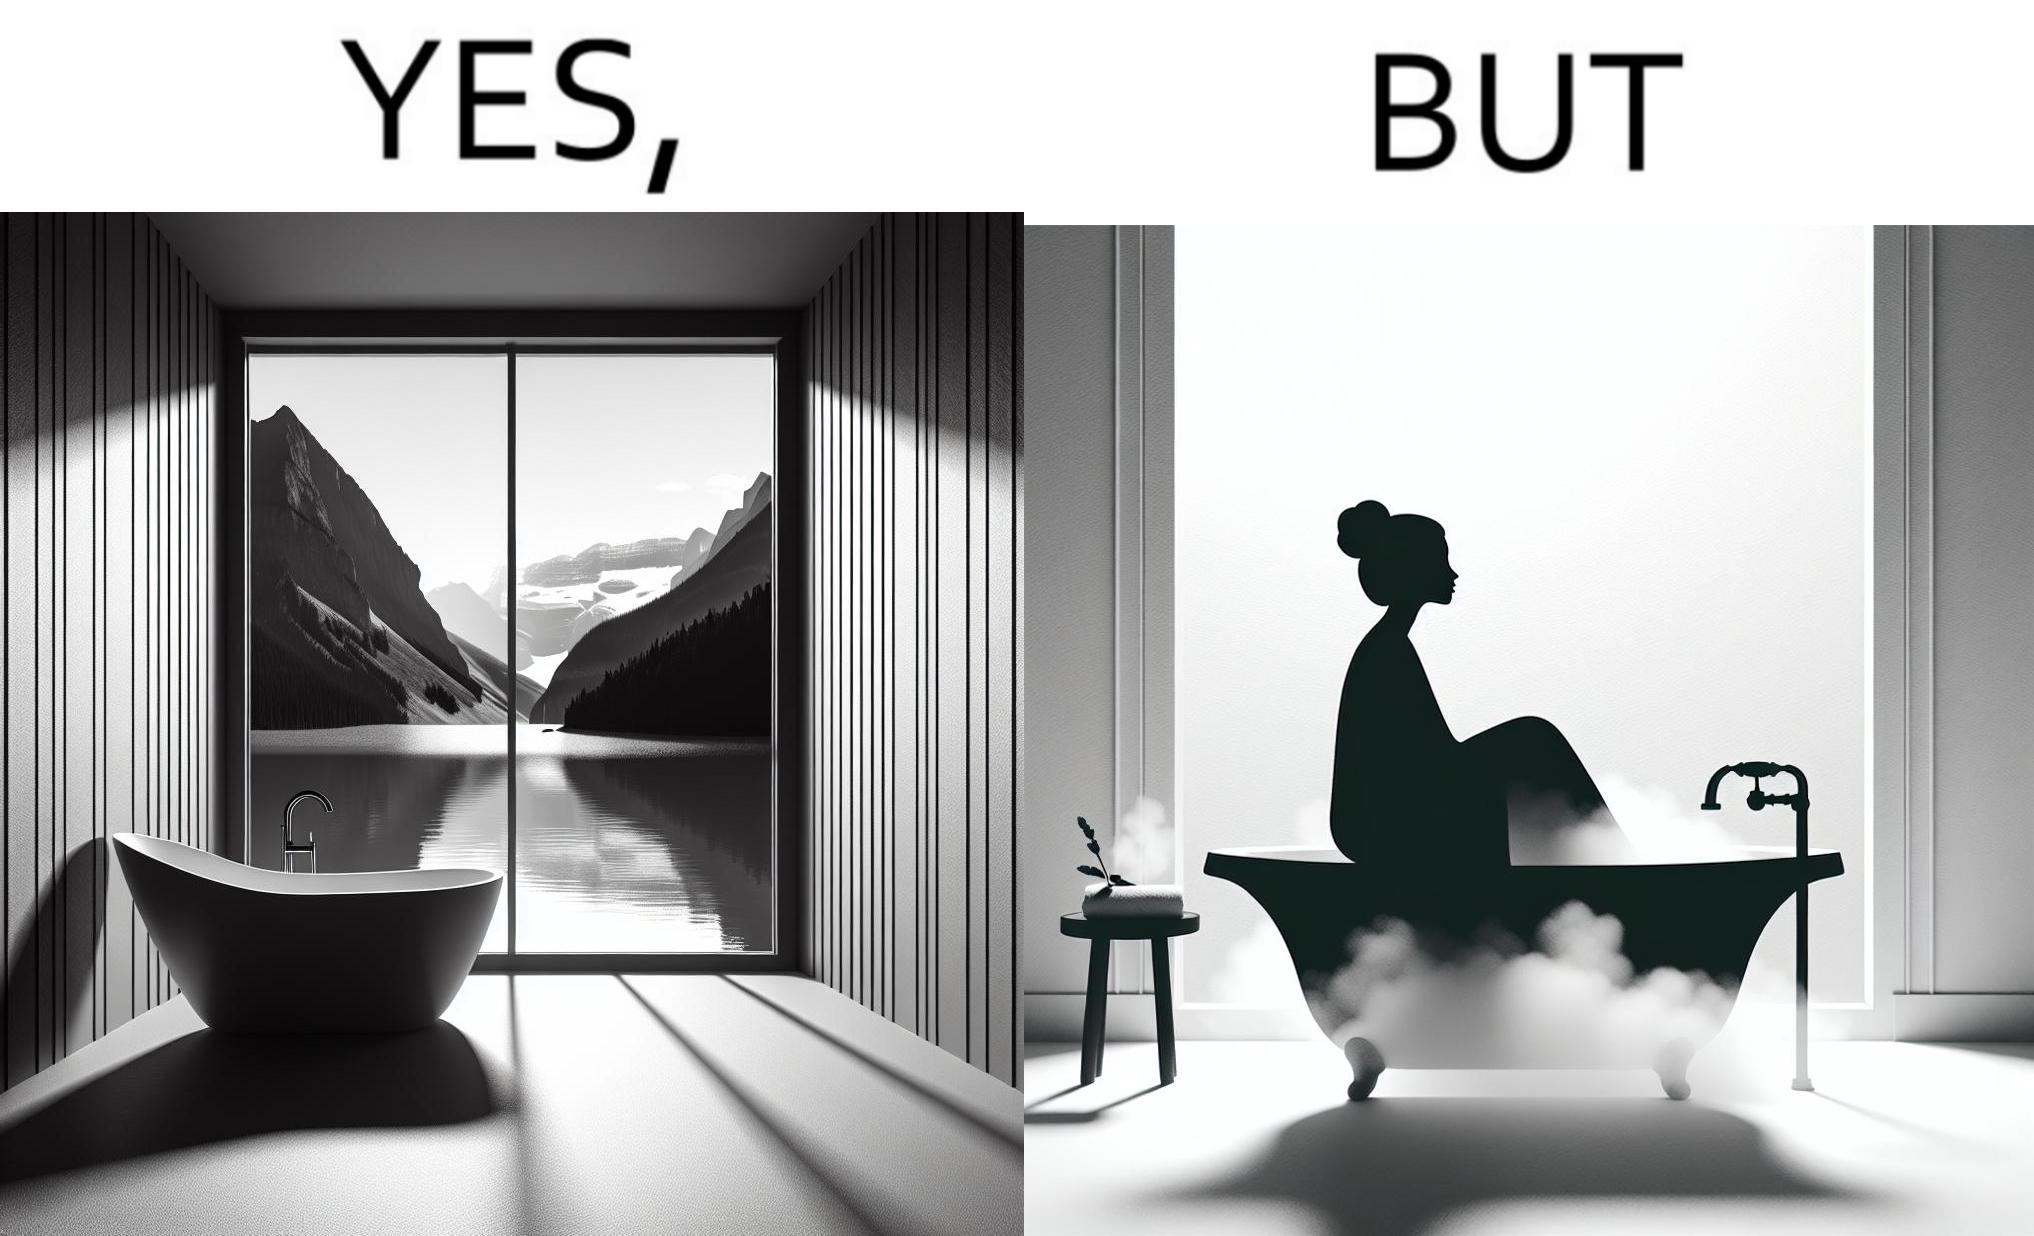What is the satirical meaning behind this image? The image is ironical, as a bathtub near a window having a very scenic view, becomes misty when someone is bathing, thus making the scenic view blurry. 